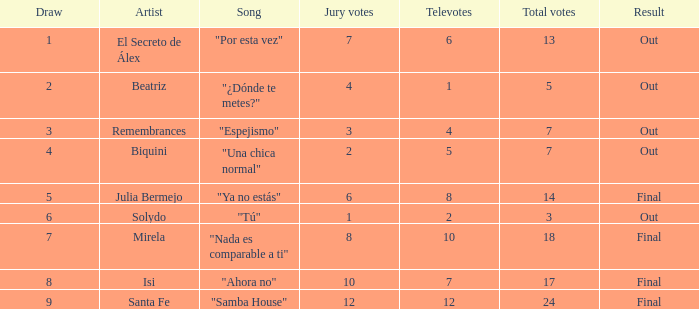What is the quantity of julia bermejo's songs? 1.0. 